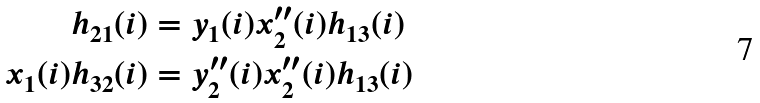Convert formula to latex. <formula><loc_0><loc_0><loc_500><loc_500>h _ { 2 1 } ( i ) & = y _ { 1 } ( i ) x _ { 2 } ^ { \prime \prime } ( i ) h _ { 1 3 } ( i ) \\ x _ { 1 } ( i ) h _ { 3 2 } ( i ) & = y _ { 2 } ^ { \prime \prime } ( i ) x _ { 2 } ^ { \prime \prime } ( i ) h _ { 1 3 } ( i )</formula> 